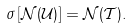<formula> <loc_0><loc_0><loc_500><loc_500>\sigma \left [ { \mathcal { N } } ( { \mathcal { U } } ) \right ] = { \mathcal { N } } ( { \mathcal { T } } ) .</formula> 